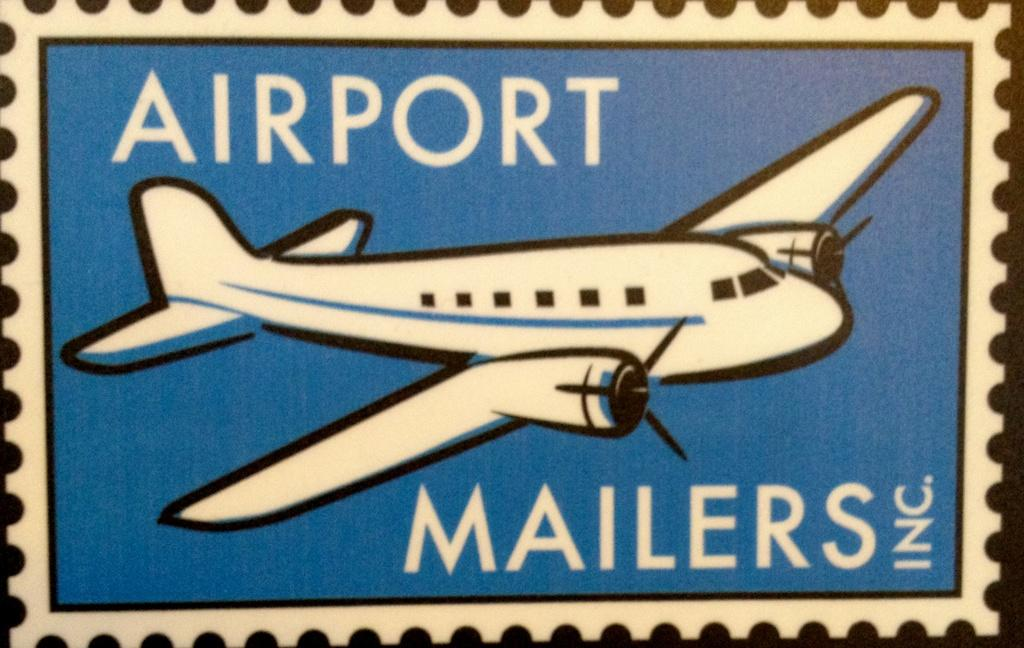What is the main subject of the poster in the image? The main subject of the poster in the image is an aeroplane. Where is the text located on the poster? There is text on the top and bottom of the poster. Can you see an owl sitting on the grass in the image? There is no owl or grass present in the image; it features a poster with an aeroplane and text. 